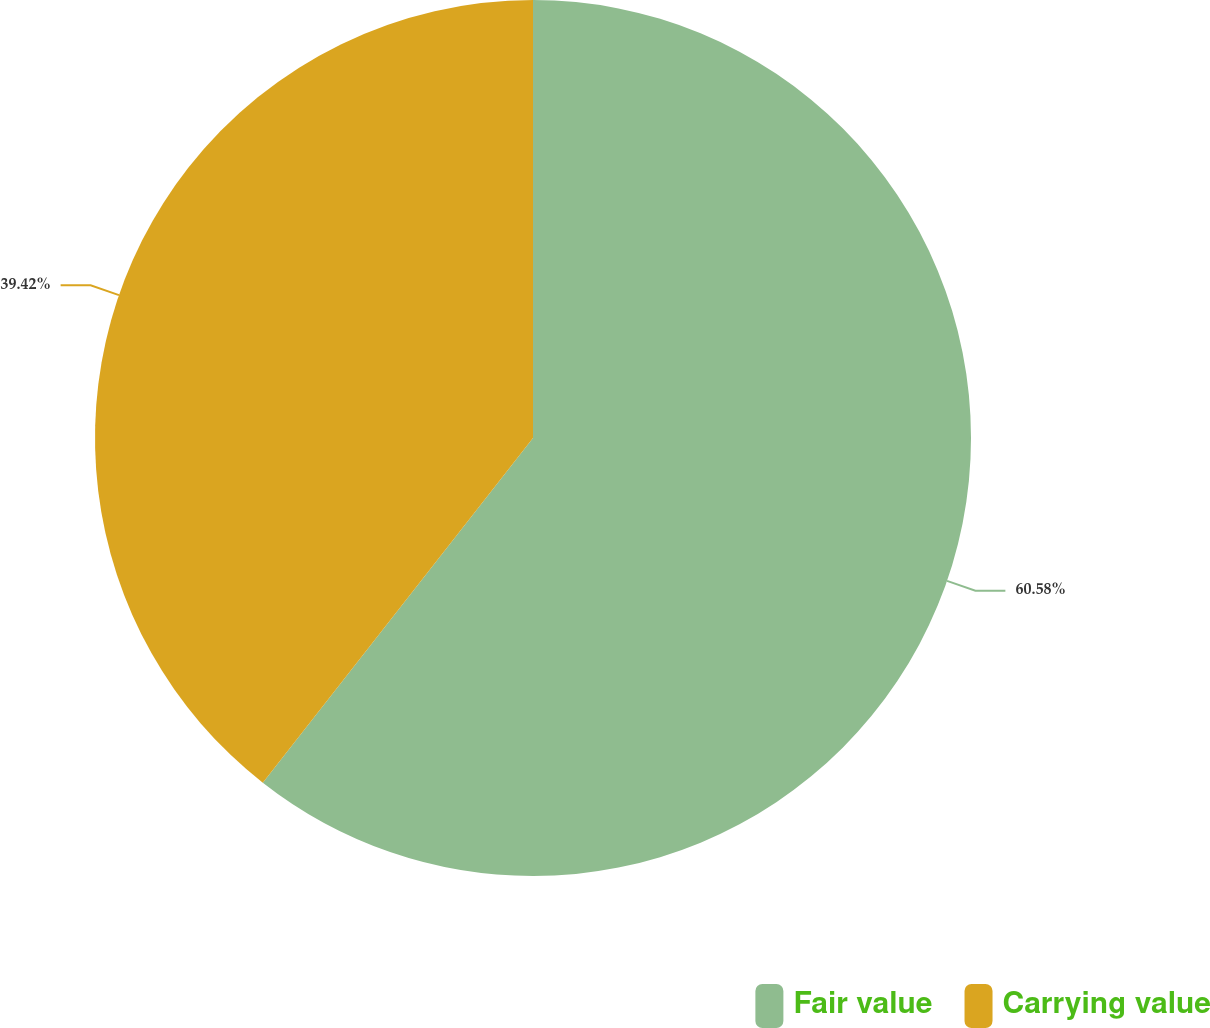<chart> <loc_0><loc_0><loc_500><loc_500><pie_chart><fcel>Fair value<fcel>Carrying value<nl><fcel>60.58%<fcel>39.42%<nl></chart> 